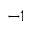Convert formula to latex. <formula><loc_0><loc_0><loc_500><loc_500>^ { - 1 }</formula> 